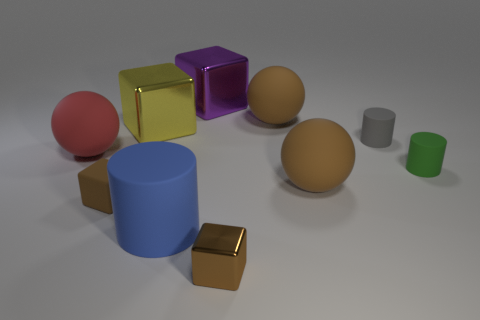Subtract all cubes. How many objects are left? 6 Subtract 0 green balls. How many objects are left? 10 Subtract all blue balls. Subtract all big things. How many objects are left? 4 Add 1 yellow shiny cubes. How many yellow shiny cubes are left? 2 Add 1 green cylinders. How many green cylinders exist? 2 